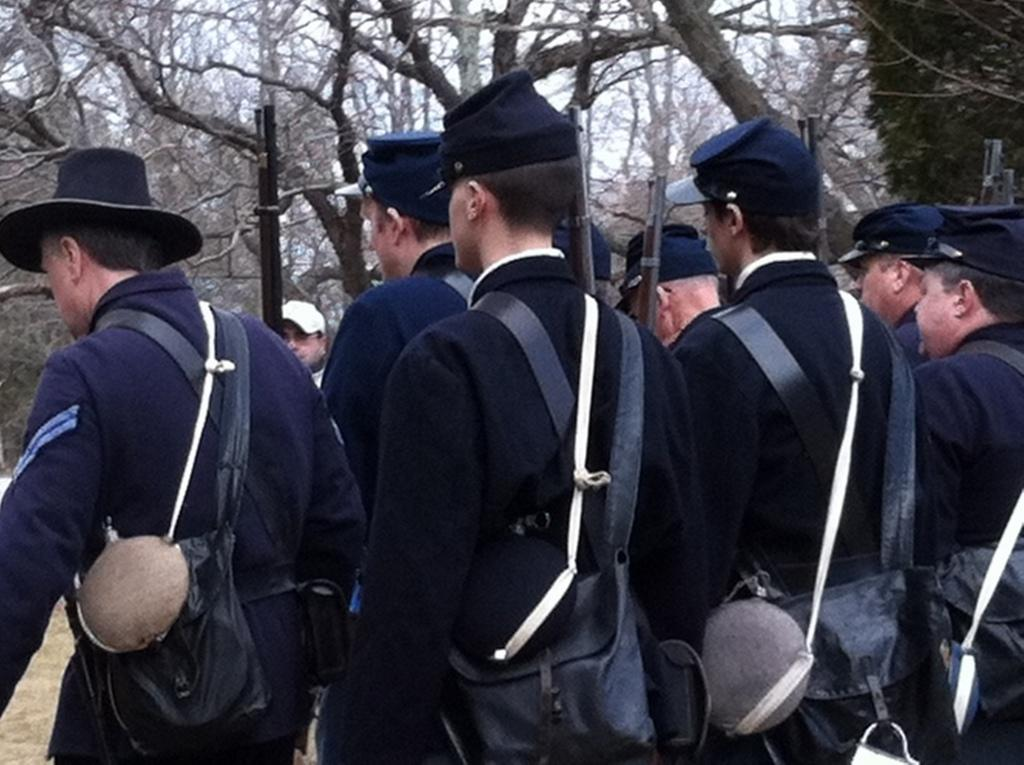Who or what is present in the image? There are people in the image. What are the people wearing? The people are wearing blue dresses and caps. What are the people holding in their hands? The people are holding guns. What can be seen at the bottom of the image? There is a ground visible at the bottom of the image. What is visible in the background of the image? There are trees in the background of the image. Can you see any spots on the tooth of the person in the image? There is no tooth visible in the image, and therefore no spots can be observed. 